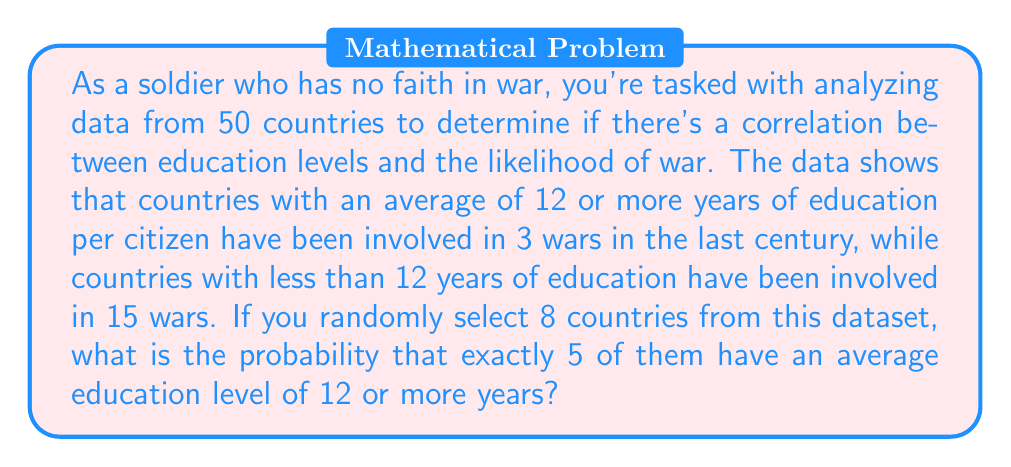Provide a solution to this math problem. To solve this problem, we'll use the binomial probability formula, as we're dealing with a fixed number of independent trials (selecting 8 countries) with two possible outcomes for each trial (12+ years of education or not).

Let's break it down step-by-step:

1. Identify the parameters:
   - $n$ = number of trials = 8
   - $k$ = number of successes = 5
   - $p$ = probability of success (12+ years of education)
   
2. Calculate $p$:
   Total countries: 50
   Countries with 12+ years: 50 - 15 = 35
   $p = \frac{35}{50} = 0.7$

3. Use the binomial probability formula:

   $$P(X = k) = \binom{n}{k} p^k (1-p)^{n-k}$$

   Where $\binom{n}{k}$ is the binomial coefficient, calculated as:

   $$\binom{n}{k} = \frac{n!}{k!(n-k)!}$$

4. Calculate the binomial coefficient:
   
   $$\binom{8}{5} = \frac{8!}{5!(8-5)!} = \frac{8!}{5!3!} = 56$$

5. Plug all values into the formula:

   $$P(X = 5) = 56 \cdot (0.7)^5 \cdot (1-0.7)^{8-5}$$
   $$= 56 \cdot (0.7)^5 \cdot (0.3)^3$$
   $$= 56 \cdot 0.16807 \cdot 0.027$$
   $$= 0.2541$$

The probability is approximately 0.2541 or 25.41%.
Answer: 0.2541 or 25.41% 